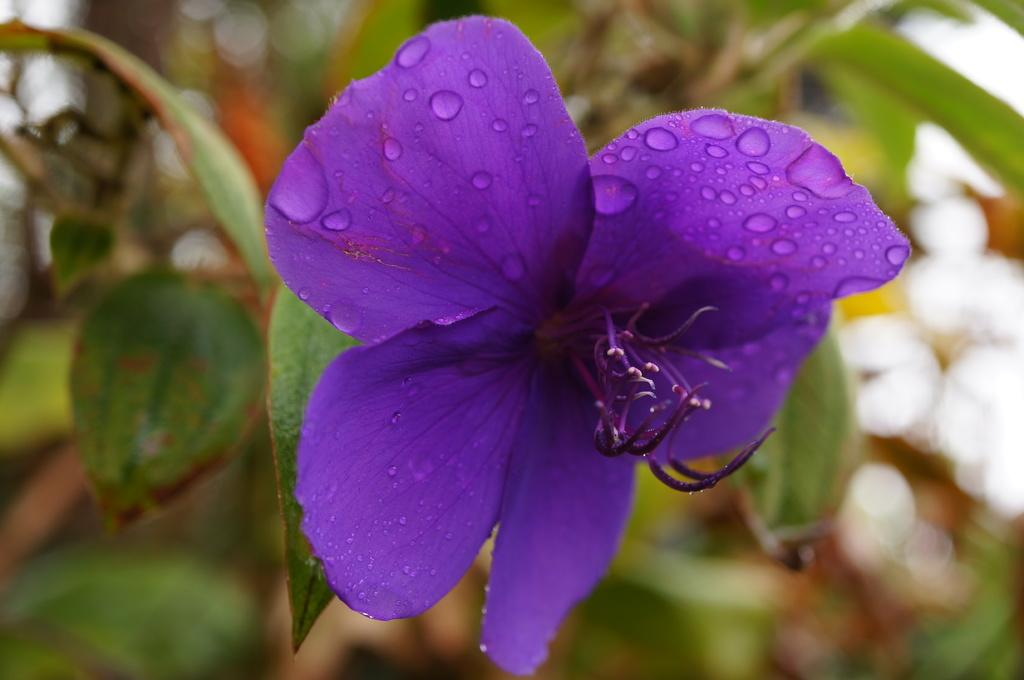What type of plant can be seen in the image? There is a plant with a flower in the image. Can you describe the background of the image? The background of the image is blurred. How many points are visible on the cloud in the image? There is no cloud present in the image, and therefore no points can be observed on it. 